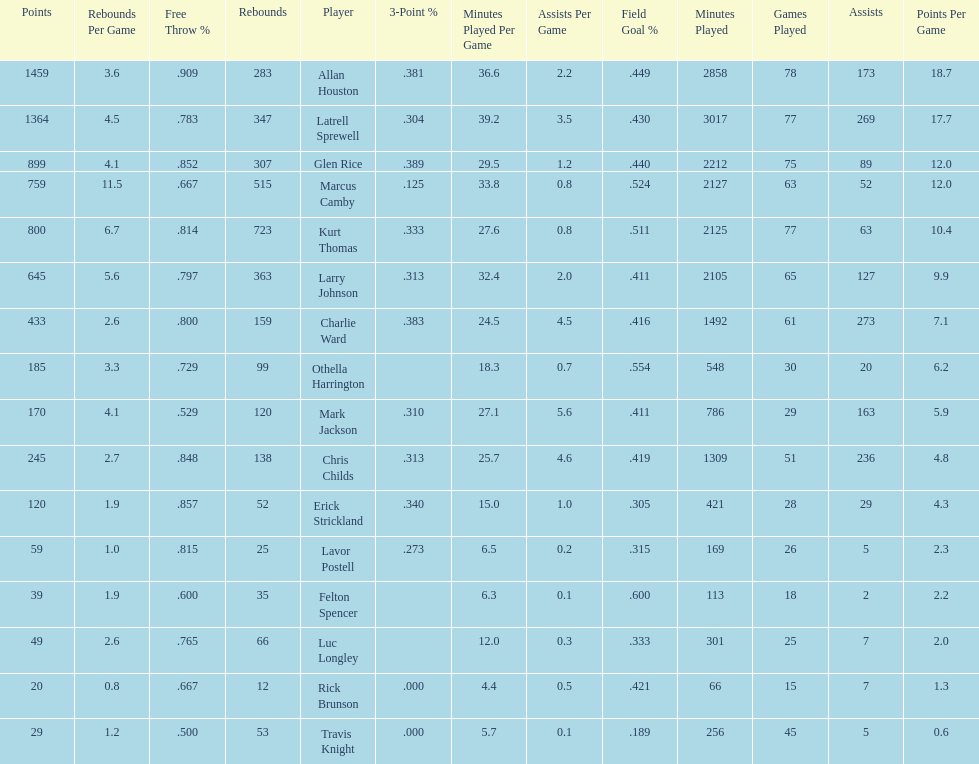How many total points were scored by players averaging over 4 assists per game> 848. 